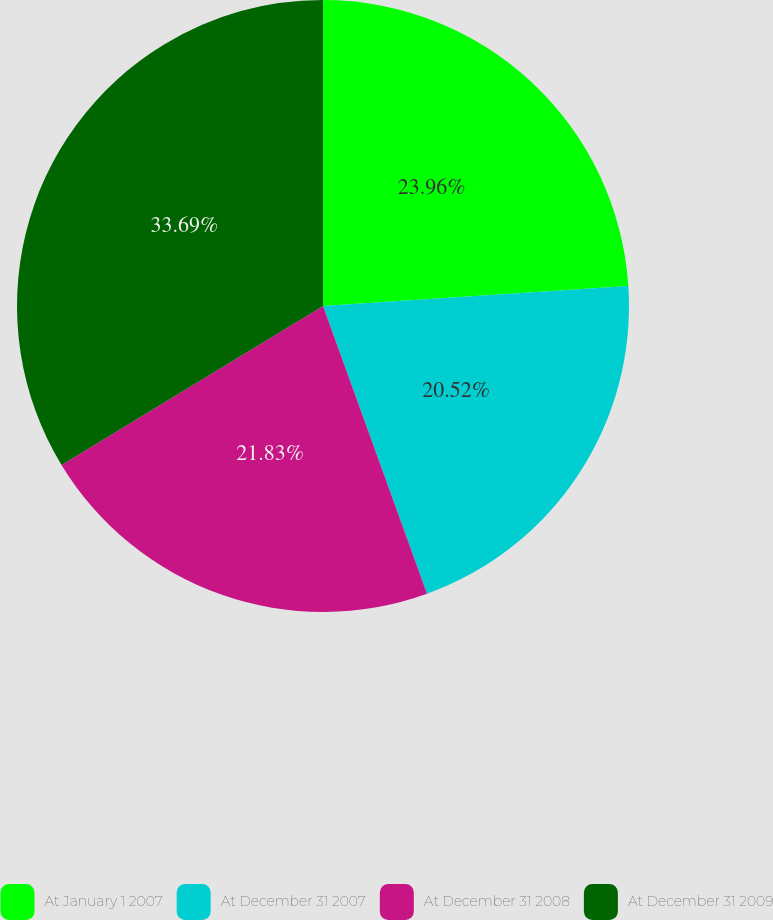Convert chart to OTSL. <chart><loc_0><loc_0><loc_500><loc_500><pie_chart><fcel>At January 1 2007<fcel>At December 31 2007<fcel>At December 31 2008<fcel>At December 31 2009<nl><fcel>23.96%<fcel>20.52%<fcel>21.83%<fcel>33.69%<nl></chart> 